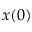Convert formula to latex. <formula><loc_0><loc_0><loc_500><loc_500>x ( 0 )</formula> 